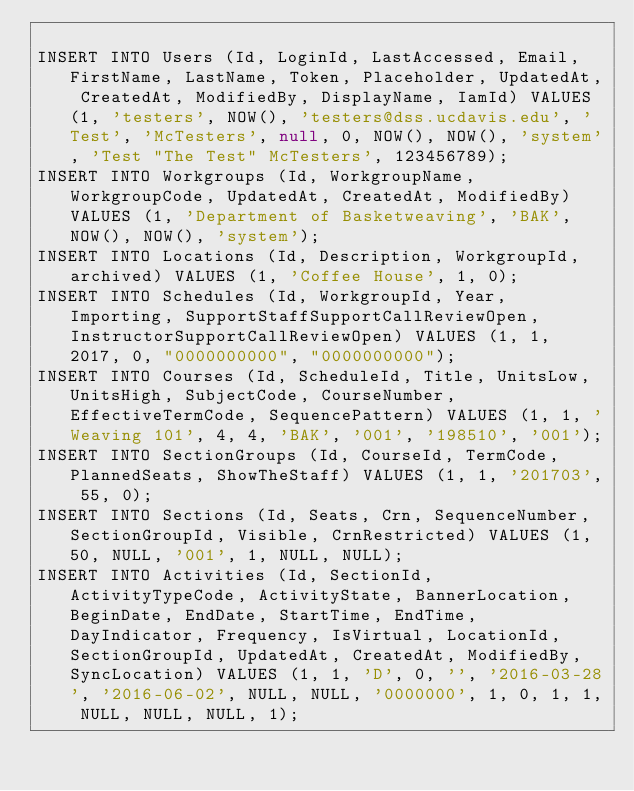Convert code to text. <code><loc_0><loc_0><loc_500><loc_500><_SQL_>
INSERT INTO Users (Id, LoginId, LastAccessed, Email, FirstName, LastName, Token, Placeholder, UpdatedAt, CreatedAt, ModifiedBy, DisplayName, IamId) VALUES (1, 'testers', NOW(), 'testers@dss.ucdavis.edu', 'Test', 'McTesters', null, 0, NOW(), NOW(), 'system', 'Test "The Test" McTesters', 123456789);
INSERT INTO Workgroups (Id, WorkgroupName, WorkgroupCode, UpdatedAt, CreatedAt, ModifiedBy) VALUES (1, 'Department of Basketweaving', 'BAK', NOW(), NOW(), 'system');
INSERT INTO Locations (Id, Description, WorkgroupId, archived) VALUES (1, 'Coffee House', 1, 0);
INSERT INTO Schedules (Id, WorkgroupId, Year, Importing, SupportStaffSupportCallReviewOpen, InstructorSupportCallReviewOpen) VALUES (1, 1, 2017, 0, "0000000000", "0000000000");
INSERT INTO Courses (Id, ScheduleId, Title, UnitsLow, UnitsHigh, SubjectCode, CourseNumber, EffectiveTermCode, SequencePattern) VALUES (1, 1, 'Weaving 101', 4, 4, 'BAK', '001', '198510', '001');
INSERT INTO SectionGroups (Id, CourseId, TermCode, PlannedSeats, ShowTheStaff) VALUES (1, 1, '201703', 55, 0);
INSERT INTO Sections (Id, Seats, Crn, SequenceNumber, SectionGroupId, Visible, CrnRestricted) VALUES (1, 50, NULL, '001', 1, NULL, NULL);
INSERT INTO Activities (Id, SectionId, ActivityTypeCode, ActivityState, BannerLocation, BeginDate, EndDate, StartTime, EndTime, DayIndicator, Frequency, IsVirtual, LocationId, SectionGroupId, UpdatedAt, CreatedAt, ModifiedBy, SyncLocation) VALUES (1, 1, 'D', 0, '', '2016-03-28', '2016-06-02', NULL, NULL, '0000000', 1, 0, 1, 1, NULL, NULL, NULL, 1);
</code> 